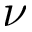<formula> <loc_0><loc_0><loc_500><loc_500>\nu</formula> 